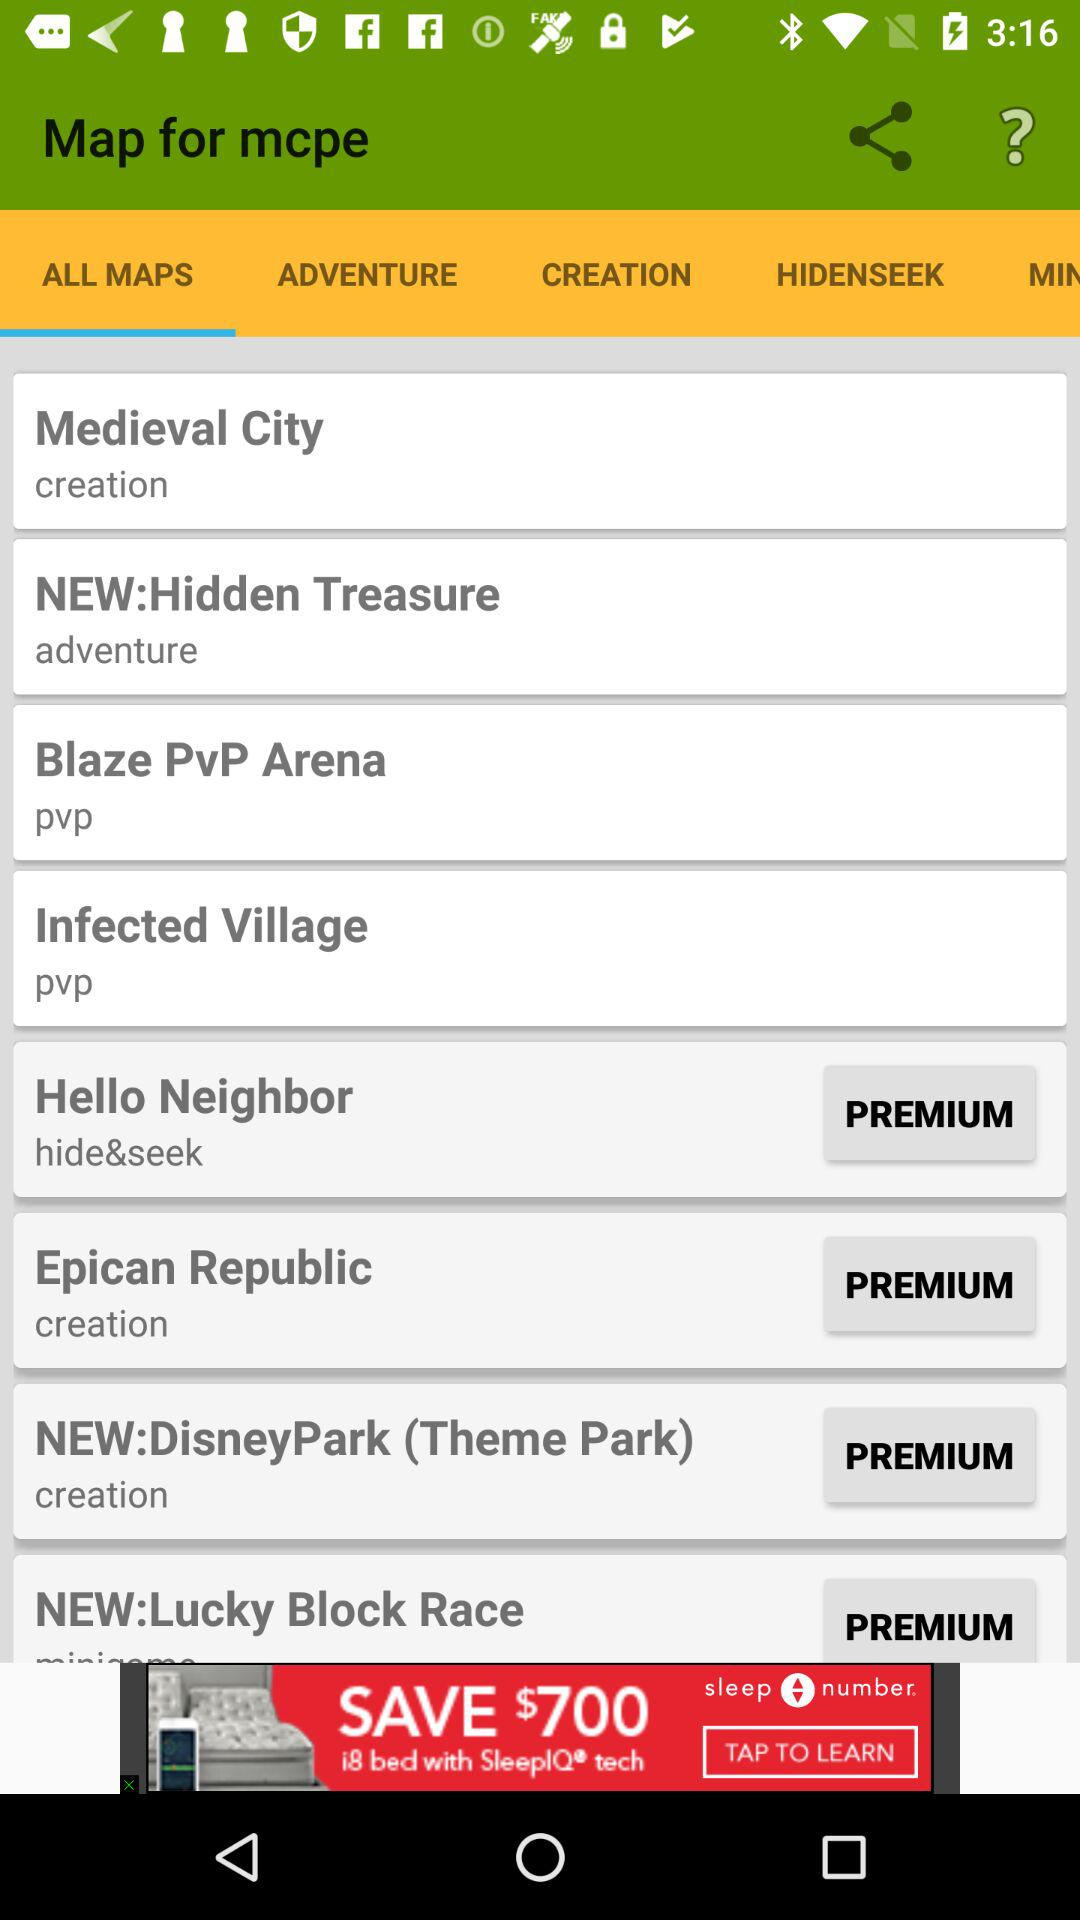How many items are in "CREATION"?
When the provided information is insufficient, respond with <no answer>. <no answer> 